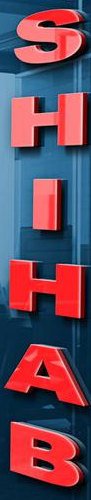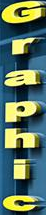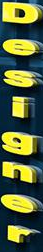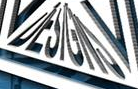What text appears in these images from left to right, separated by a semicolon? SHIHAB; Graphic; Designer; DESIGNS 